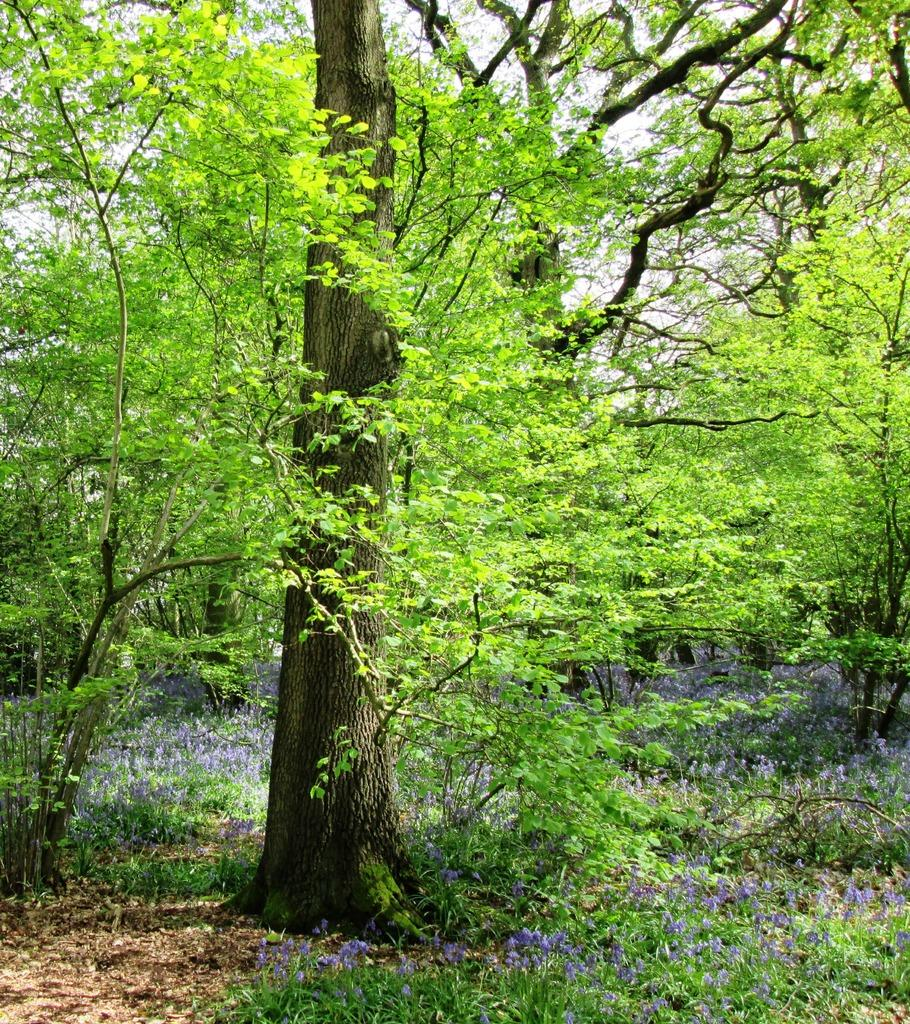What type of vegetation is in the middle of the image? There are trees in the middle of the image. What other type of vegetation can be seen on the ground? There are plants on the ground. What can be seen in the background of the image? There is sky visible in the background of the image. Where is the prison located in the image? There is no prison present in the image; it features trees and plants. What type of bulb is used to light up the area in the image? There is no mention of a bulb or any artificial lighting in the image, as it appears to be outdoors and naturally lit by the sky. 